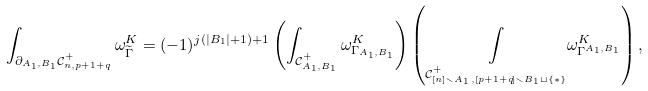<formula> <loc_0><loc_0><loc_500><loc_500>\int _ { \partial _ { A _ { 1 } , B _ { 1 } } \mathcal { C } _ { n , p + 1 + q } ^ { + } } \omega ^ { K } _ { \widetilde { \Gamma } } = ( - 1 ) ^ { j ( | B _ { 1 } | + 1 ) + 1 } \left ( \int _ { \mathcal { C } _ { A _ { 1 } , B _ { 1 } } ^ { + } } \omega ^ { K } _ { \Gamma _ { A _ { 1 } , B _ { 1 } } } \right ) \left ( \underset { \mathcal { C } _ { [ n ] \smallsetminus A _ { 1 } , [ p + 1 + q ] \smallsetminus B _ { 1 } \sqcup \{ * \} } ^ { + } } \int \omega ^ { K } _ { \Gamma ^ { A _ { 1 } , B _ { 1 } } } \right ) ,</formula> 